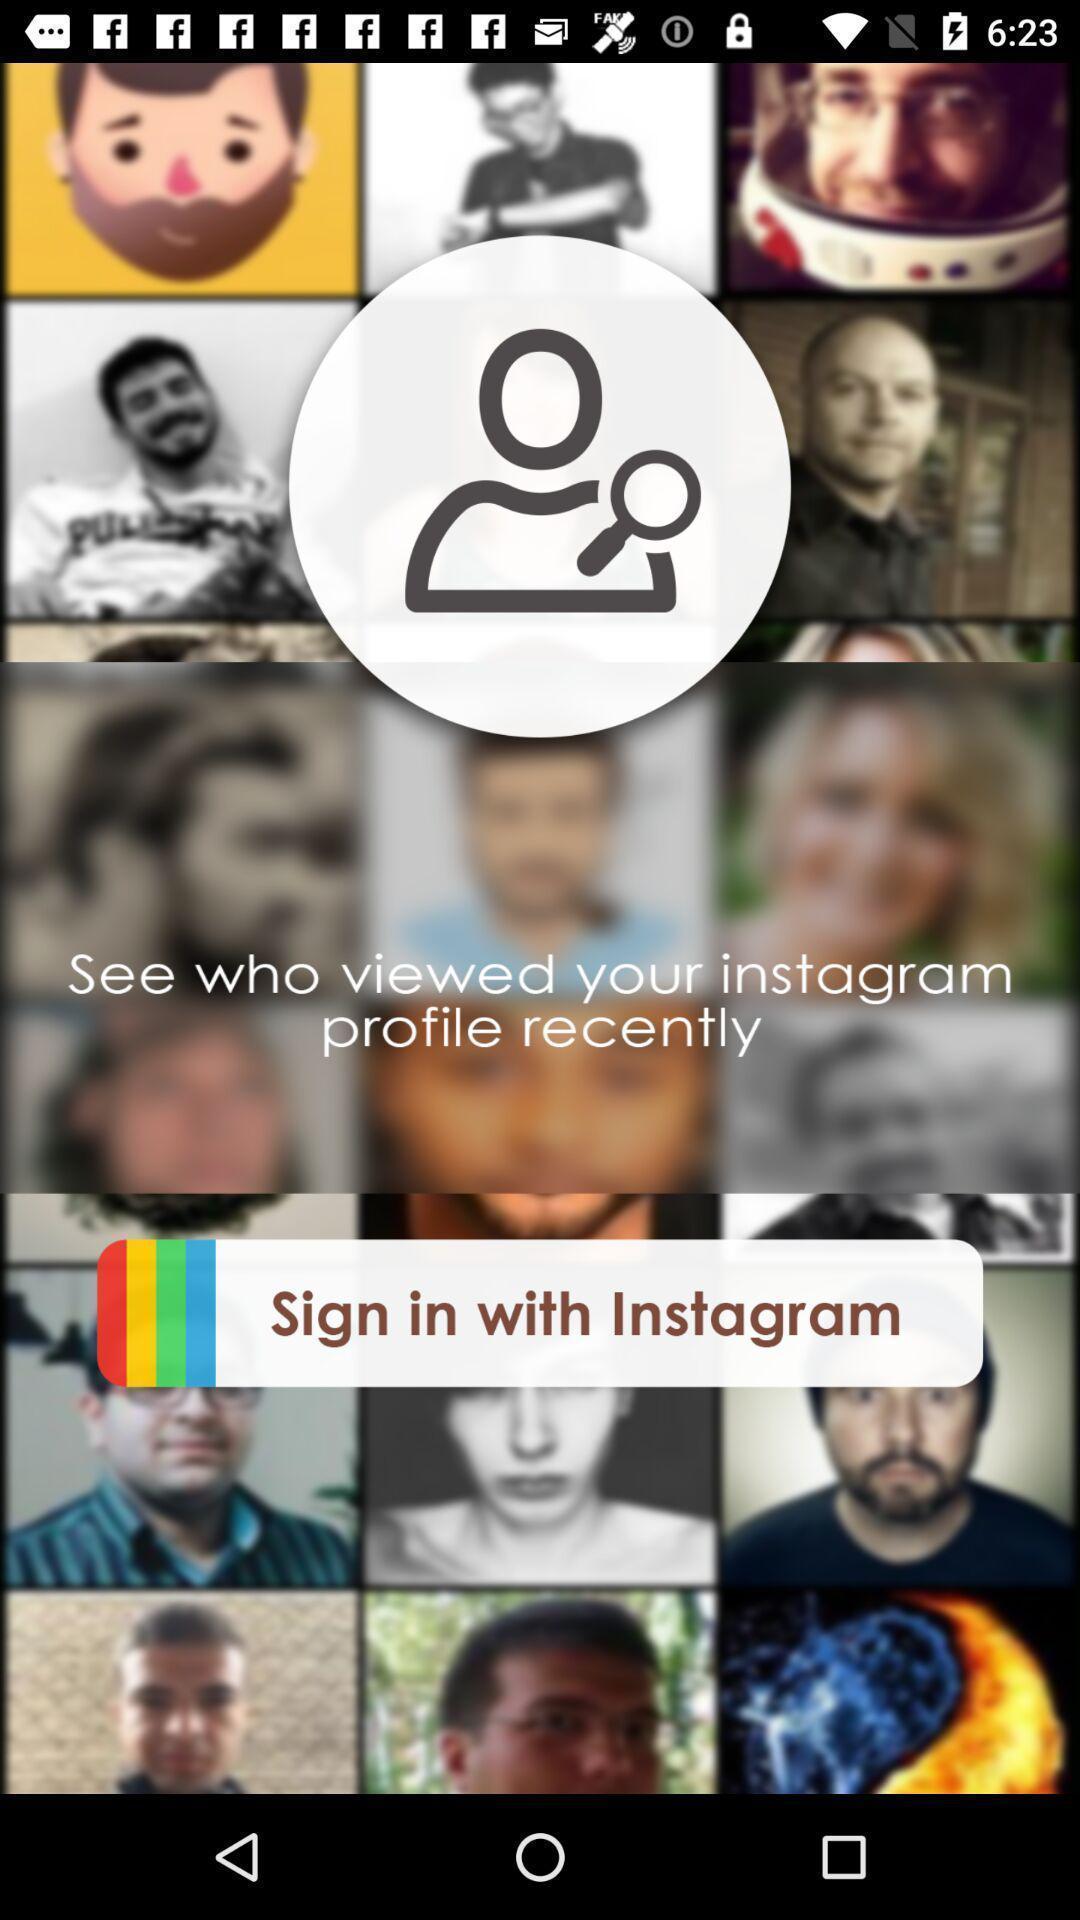Tell me what you see in this picture. Sign in page. 